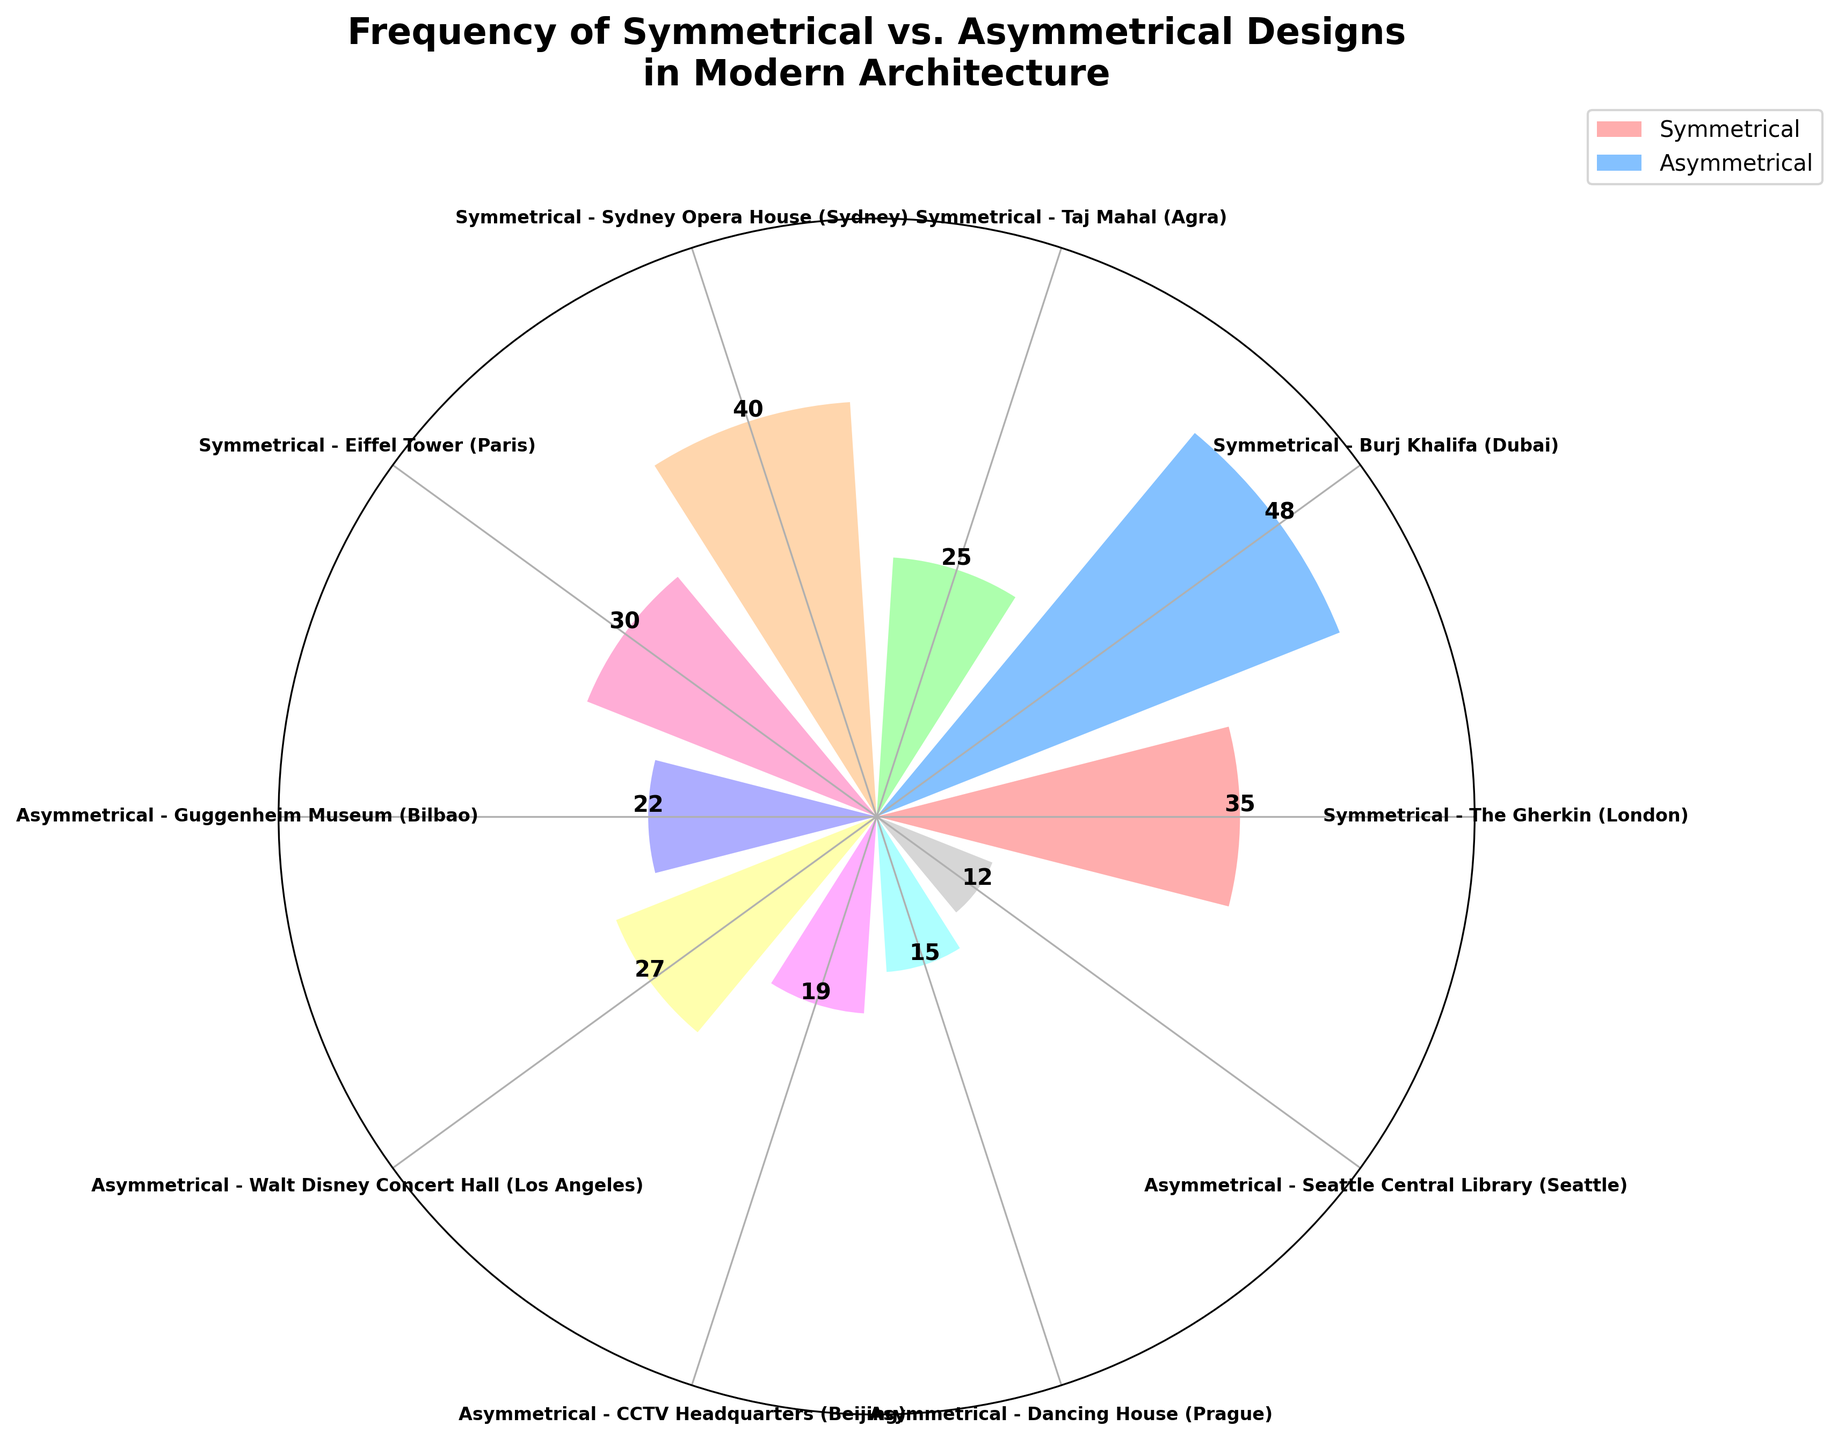What is the title of the plot? The title of the plot is usually placed at the top of the figure, explaining the main subject of the chart. In this case, the title reads, "Frequency of Symmetrical vs. Asymmetrical Designs in Modern Architecture."
Answer: Frequency of Symmetrical vs. Asymmetrical Designs in Modern Architecture How many total designs are represented in the plot? To find the total number of designs, count the number of bars or entries in the legend. The data has 10 entries, each representing a different design.
Answer: 10 Which design has the highest frequency and what is its value? Identify the tallest bar in the plot. The Burj Khalifa (Dubai) is labeled with a frequency of 48, making it the highest.
Answer: Burj Khalifa (48) What is the color used for symmetrical designs in the plot? Symmetrical designs all share a particular color. In the legend, symmetrical designs are represented by a shade of red or pink.
Answer: Red/Pink What is the sum of frequencies for asymmetrical designs? List the frequencies for all asymmetrical designs and sum them: 22 (Guggenheim Museum) + 27 (Walt Disney Concert Hall) + 19 (CCTV Headquarters) + 15 (Dancing House) + 12 (Seattle Central Library). The total is 95.
Answer: 95 How many more times frequent is the most common symmetrical design compared to the most common asymmetrical design? The most common symmetrical design is the Burj Khalifa with a frequency of 48. The most common asymmetrical design is the Walt Disney Concert Hall with a frequency of 27. The difference is 48 - 27 = 21.
Answer: 21 What is the average frequency of the symmetrical designs? List the frequencies for all symmetrical designs, sum them, and divide by the number of symmetrical designs: (35 + 48 + 25 + 40 + 30) / 5 = 178 / 5 = 35.6
Answer: 35.6 Is there a design type that appears to have more frequent entries overall, symmetrical or asymmetrical? Compare the total frequencies of both design types. Sum of symmetrical frequencies: 35 + 48 + 25 + 40 + 30 = 178. Sum of asymmetrical frequencies: 22 + 27 + 19 + 15 + 12 = 95. Symmetrical designs have higher total frequencies.
Answer: Symmetrical Which design has the lowest frequency and what is its value? Identify the shortest bar in the plot. The Seattle Central Library (Seattle) is labeled with a frequency of 12, making it the lowest.
Answer: Seattle Central Library (12) How does the frequency of the Eiffel Tower compare to the frequency of the Sydney Opera House? The frequency of the Eiffel Tower (30) and the frequency of the Sydney Opera House (40) are compared. The Sydney Opera House is more frequent by 10.
Answer: Sydney Opera House by 10 